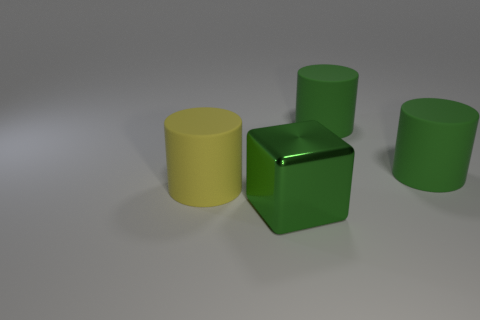Is the number of rubber objects on the left side of the yellow matte cylinder greater than the number of yellow rubber cylinders on the left side of the big green cube?
Your answer should be very brief. No. How big is the green block?
Your answer should be very brief. Large. What number of things are big objects or cubes?
Ensure brevity in your answer.  4. How many matte cylinders are left of the metallic thing and on the right side of the metallic thing?
Make the answer very short. 0. Is there a big rubber cylinder behind the big cylinder that is to the left of the green object that is in front of the yellow matte object?
Offer a very short reply. Yes. What is the shape of the yellow thing that is the same size as the green metallic thing?
Ensure brevity in your answer.  Cylinder. Are there any big rubber cylinders that have the same color as the shiny thing?
Make the answer very short. Yes. How many big objects are shiny cubes or gray metallic spheres?
Your response must be concise. 1. What number of other things have the same material as the large yellow thing?
Provide a short and direct response. 2. There is a green object that is in front of the yellow cylinder; is its size the same as the object that is on the left side of the big metal cube?
Provide a succinct answer. Yes. 